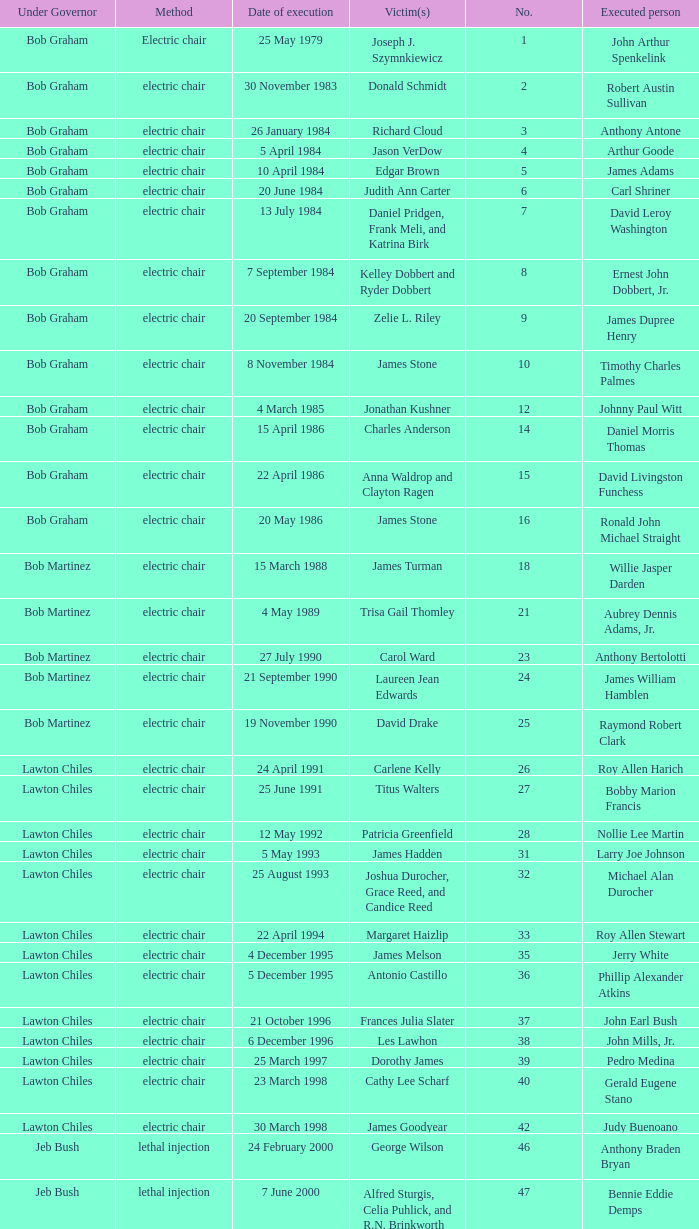What's the name of Linroy Bottoson's victim? Catherine Alexander. 